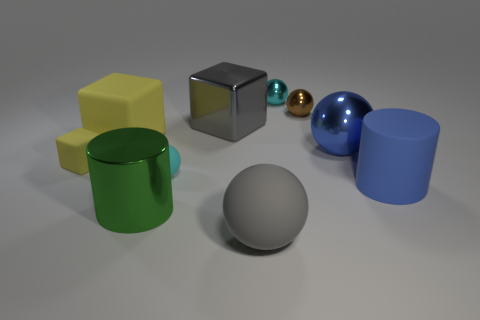Subtract all cyan spheres. How many spheres are left? 3 Subtract all small matte spheres. How many spheres are left? 4 Subtract all yellow balls. Subtract all cyan cylinders. How many balls are left? 5 Subtract all cubes. How many objects are left? 7 Add 1 tiny blocks. How many tiny blocks are left? 2 Add 6 blue shiny cubes. How many blue shiny cubes exist? 6 Subtract 0 brown cylinders. How many objects are left? 10 Subtract all large rubber cylinders. Subtract all tiny matte things. How many objects are left? 7 